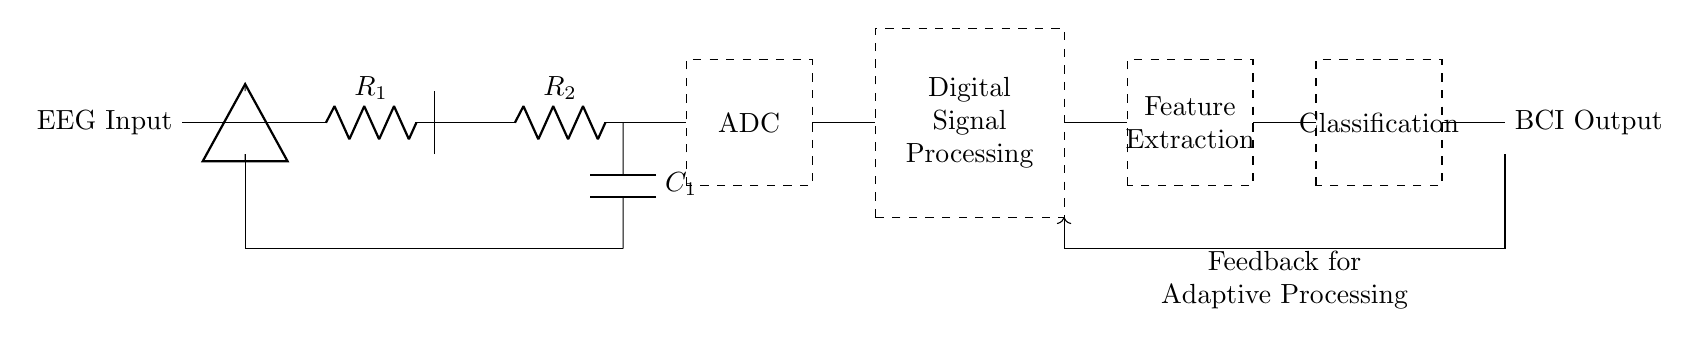What is the first component in the circuit? The first component shown in the circuit is the EEG Input, which is indicated on the left side as the starting point of the circuit.
Answer: EEG Input What type of filter is used in this circuit? The circuit contains an analog filter indicated by the resistor and capacitor connected between the input and output sections, signifying its filtering role for the EEG signals.
Answer: Analog Filter What is the purpose of the ADC in the circuit? The ADC, or Analog-to-Digital Converter, is responsible for converting the analog signals from the EEG into digital signals that can be processed in the digital signal processing section of the circuit.
Answer: Conversion How many main stages are there in the digital processing section? There are three main stages in the digital processing section: feature extraction, classification, and the feedback loop, which together allow for adaptive processing of the EEG signals.
Answer: Three What does the feedback loop provide for the processing? The feedback loop in the circuit is designed to provide adaptive processing by allowing modifications based on the output classification results, enhancing the accuracy and efficiency of the BCI system.
Answer: Adaptive Processing What element is used to enhance the EEG signal before digitization? The pre-amplifier, shown after the EEG Input, is used to amplify the small EEG signals to a higher level suitable for further processing before it reaches the ADC.
Answer: Pre-amplifier What role does the feature extraction play in the circuit? The feature extraction stage processes the digitized EEG signals to identify relevant patterns that can be used for classification, which is critical for translating brain signals into actionable outputs in a brain-computer interface.
Answer: Pattern Identification 